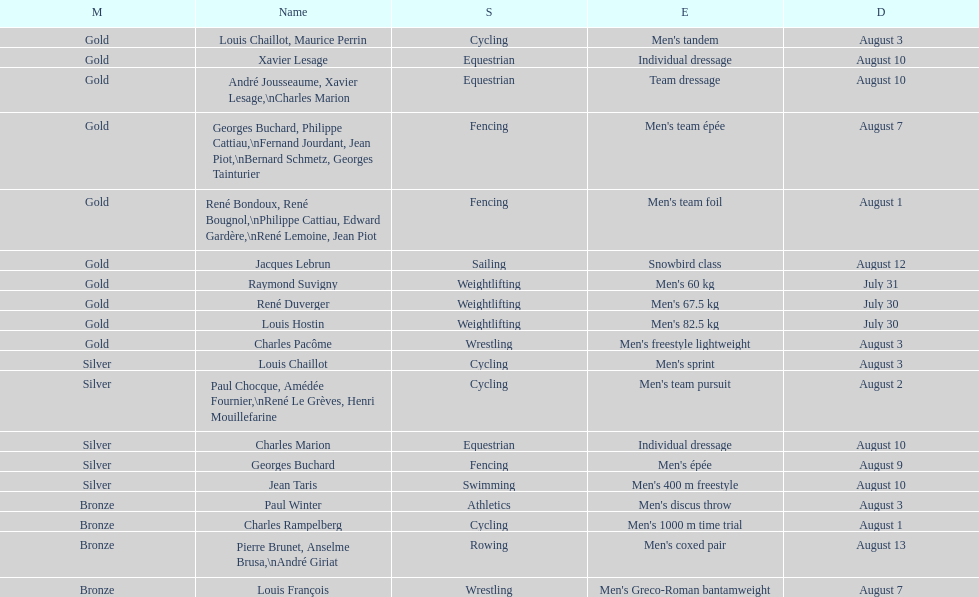In which event were the most medals obtained? Cycling. 